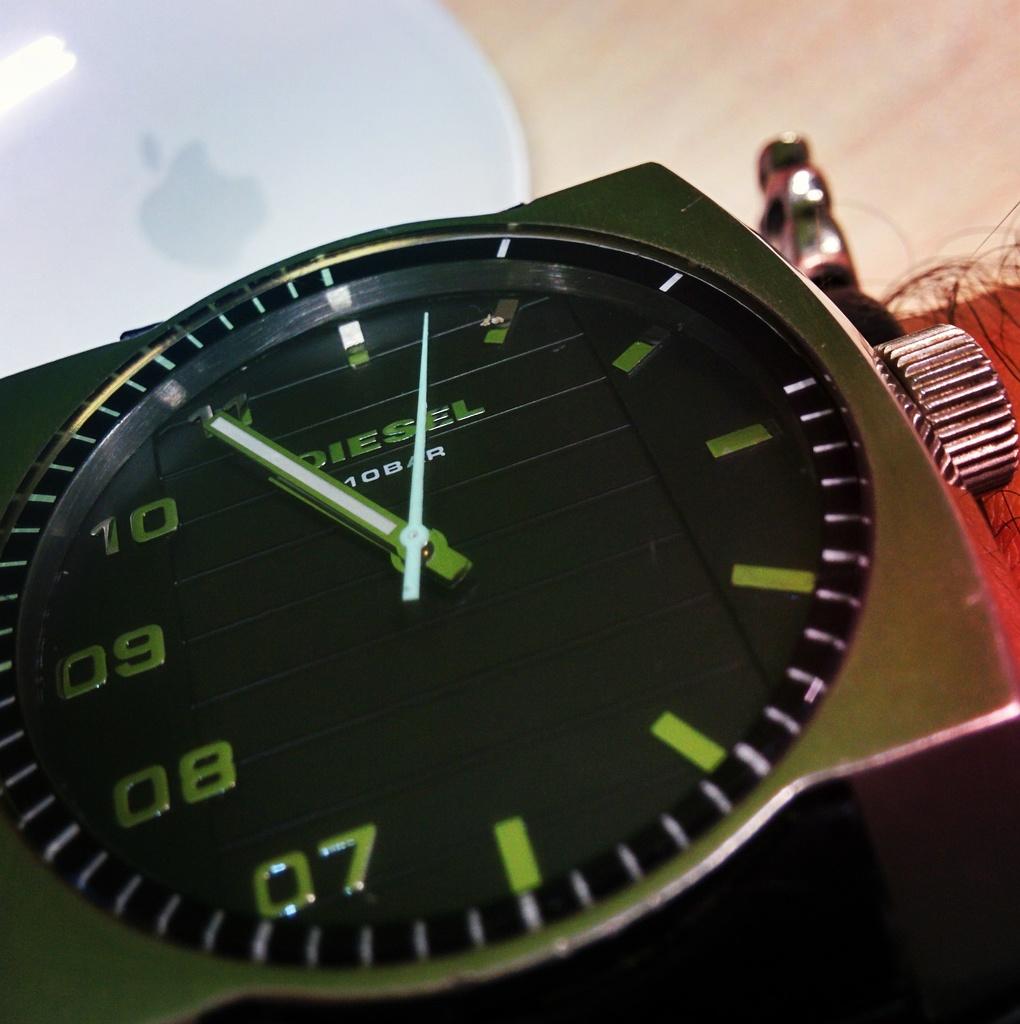What time is it?
Offer a very short reply. 10:55. What numbers are along the left?
Provide a short and direct response. 07 08 09 10 11. 